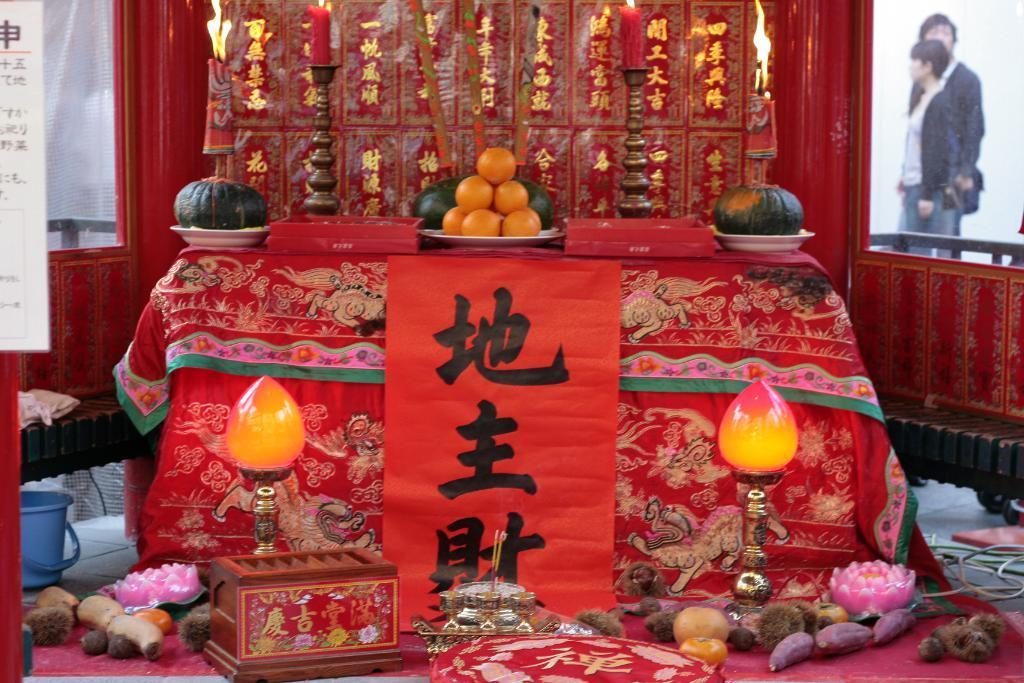Describe this image in one or two sentences. In this image there are candles on the stand, there are objects on the surface, there are objects on the floor, there is a bucket on the floor, there are wires truncated towards the right of the image, there are objects truncated towards the right of the image, there are two persons standing, there is a board truncated towards the left of the image, there is cloth on the surface, there is a red color wall, there are windows. 